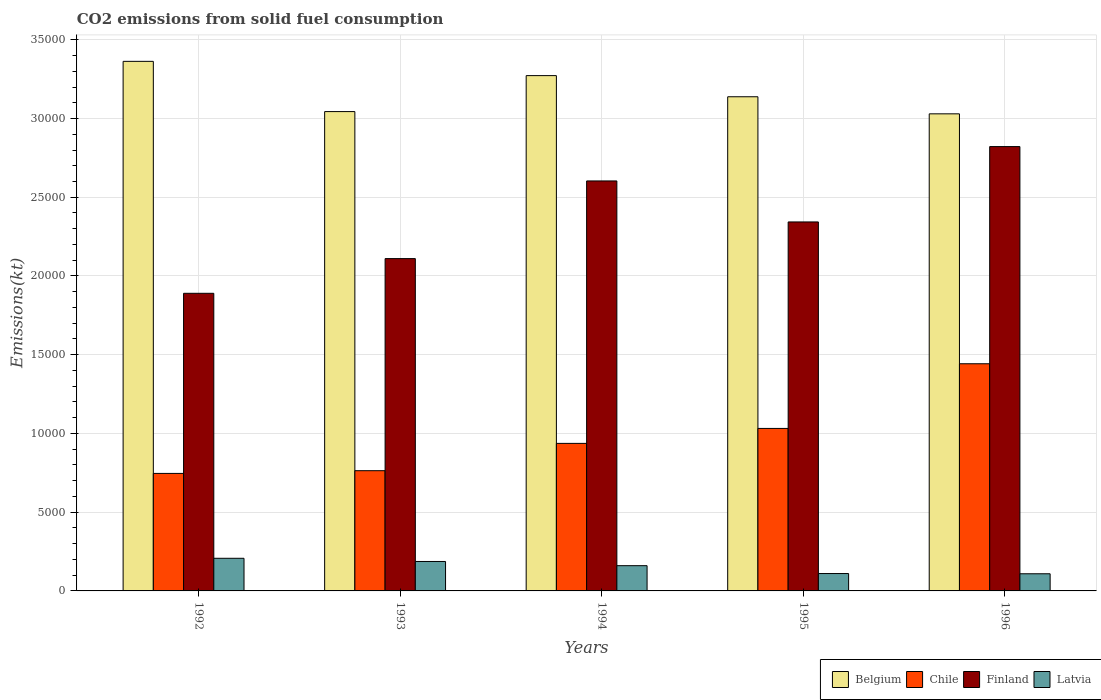How many different coloured bars are there?
Provide a short and direct response. 4. Are the number of bars per tick equal to the number of legend labels?
Your response must be concise. Yes. Are the number of bars on each tick of the X-axis equal?
Offer a terse response. Yes. How many bars are there on the 1st tick from the right?
Offer a very short reply. 4. In how many cases, is the number of bars for a given year not equal to the number of legend labels?
Provide a succinct answer. 0. What is the amount of CO2 emitted in Finland in 1994?
Your answer should be very brief. 2.60e+04. Across all years, what is the maximum amount of CO2 emitted in Finland?
Keep it short and to the point. 2.82e+04. Across all years, what is the minimum amount of CO2 emitted in Latvia?
Make the answer very short. 1089.1. In which year was the amount of CO2 emitted in Latvia maximum?
Offer a terse response. 1992. What is the total amount of CO2 emitted in Chile in the graph?
Provide a succinct answer. 4.92e+04. What is the difference between the amount of CO2 emitted in Chile in 1994 and that in 1996?
Make the answer very short. -5056.79. What is the difference between the amount of CO2 emitted in Belgium in 1992 and the amount of CO2 emitted in Latvia in 1993?
Provide a short and direct response. 3.18e+04. What is the average amount of CO2 emitted in Chile per year?
Your response must be concise. 9842.23. In the year 1992, what is the difference between the amount of CO2 emitted in Chile and amount of CO2 emitted in Latvia?
Keep it short and to the point. 5390.49. What is the ratio of the amount of CO2 emitted in Latvia in 1993 to that in 1996?
Your response must be concise. 1.72. Is the difference between the amount of CO2 emitted in Chile in 1992 and 1994 greater than the difference between the amount of CO2 emitted in Latvia in 1992 and 1994?
Offer a terse response. No. What is the difference between the highest and the second highest amount of CO2 emitted in Latvia?
Your response must be concise. 201.68. What is the difference between the highest and the lowest amount of CO2 emitted in Chile?
Your answer should be compact. 6963.63. Is the sum of the amount of CO2 emitted in Chile in 1995 and 1996 greater than the maximum amount of CO2 emitted in Latvia across all years?
Your answer should be very brief. Yes. What does the 4th bar from the left in 1993 represents?
Offer a terse response. Latvia. What does the 1st bar from the right in 1993 represents?
Ensure brevity in your answer.  Latvia. How many bars are there?
Give a very brief answer. 20. How many legend labels are there?
Ensure brevity in your answer.  4. What is the title of the graph?
Offer a very short reply. CO2 emissions from solid fuel consumption. Does "American Samoa" appear as one of the legend labels in the graph?
Ensure brevity in your answer.  No. What is the label or title of the Y-axis?
Your response must be concise. Emissions(kt). What is the Emissions(kt) of Belgium in 1992?
Provide a succinct answer. 3.36e+04. What is the Emissions(kt) of Chile in 1992?
Make the answer very short. 7462.35. What is the Emissions(kt) of Finland in 1992?
Offer a very short reply. 1.89e+04. What is the Emissions(kt) of Latvia in 1992?
Make the answer very short. 2071.86. What is the Emissions(kt) of Belgium in 1993?
Provide a short and direct response. 3.04e+04. What is the Emissions(kt) of Chile in 1993?
Offer a terse response. 7634.69. What is the Emissions(kt) in Finland in 1993?
Offer a very short reply. 2.11e+04. What is the Emissions(kt) of Latvia in 1993?
Your answer should be compact. 1870.17. What is the Emissions(kt) of Belgium in 1994?
Give a very brief answer. 3.27e+04. What is the Emissions(kt) in Chile in 1994?
Your answer should be very brief. 9369.18. What is the Emissions(kt) in Finland in 1994?
Make the answer very short. 2.60e+04. What is the Emissions(kt) of Latvia in 1994?
Ensure brevity in your answer.  1602.48. What is the Emissions(kt) in Belgium in 1995?
Keep it short and to the point. 3.14e+04. What is the Emissions(kt) of Chile in 1995?
Your answer should be very brief. 1.03e+04. What is the Emissions(kt) in Finland in 1995?
Your answer should be very brief. 2.34e+04. What is the Emissions(kt) of Latvia in 1995?
Offer a terse response. 1103.77. What is the Emissions(kt) of Belgium in 1996?
Make the answer very short. 3.03e+04. What is the Emissions(kt) of Chile in 1996?
Provide a succinct answer. 1.44e+04. What is the Emissions(kt) of Finland in 1996?
Give a very brief answer. 2.82e+04. What is the Emissions(kt) in Latvia in 1996?
Your response must be concise. 1089.1. Across all years, what is the maximum Emissions(kt) in Belgium?
Provide a succinct answer. 3.36e+04. Across all years, what is the maximum Emissions(kt) in Chile?
Your response must be concise. 1.44e+04. Across all years, what is the maximum Emissions(kt) in Finland?
Your answer should be compact. 2.82e+04. Across all years, what is the maximum Emissions(kt) in Latvia?
Your answer should be compact. 2071.86. Across all years, what is the minimum Emissions(kt) of Belgium?
Your answer should be compact. 3.03e+04. Across all years, what is the minimum Emissions(kt) of Chile?
Your answer should be compact. 7462.35. Across all years, what is the minimum Emissions(kt) of Finland?
Offer a terse response. 1.89e+04. Across all years, what is the minimum Emissions(kt) of Latvia?
Your answer should be compact. 1089.1. What is the total Emissions(kt) in Belgium in the graph?
Provide a succinct answer. 1.58e+05. What is the total Emissions(kt) in Chile in the graph?
Keep it short and to the point. 4.92e+04. What is the total Emissions(kt) of Finland in the graph?
Give a very brief answer. 1.18e+05. What is the total Emissions(kt) of Latvia in the graph?
Give a very brief answer. 7737.37. What is the difference between the Emissions(kt) of Belgium in 1992 and that in 1993?
Offer a terse response. 3190.29. What is the difference between the Emissions(kt) in Chile in 1992 and that in 1993?
Offer a very short reply. -172.35. What is the difference between the Emissions(kt) in Finland in 1992 and that in 1993?
Make the answer very short. -2203.87. What is the difference between the Emissions(kt) of Latvia in 1992 and that in 1993?
Offer a terse response. 201.69. What is the difference between the Emissions(kt) in Belgium in 1992 and that in 1994?
Offer a very short reply. 905.75. What is the difference between the Emissions(kt) of Chile in 1992 and that in 1994?
Your answer should be compact. -1906.84. What is the difference between the Emissions(kt) in Finland in 1992 and that in 1994?
Your answer should be very brief. -7135.98. What is the difference between the Emissions(kt) of Latvia in 1992 and that in 1994?
Ensure brevity in your answer.  469.38. What is the difference between the Emissions(kt) of Belgium in 1992 and that in 1995?
Provide a succinct answer. 2247.87. What is the difference between the Emissions(kt) in Chile in 1992 and that in 1995?
Provide a succinct answer. -2856.59. What is the difference between the Emissions(kt) of Finland in 1992 and that in 1995?
Make the answer very short. -4532.41. What is the difference between the Emissions(kt) of Latvia in 1992 and that in 1995?
Your answer should be very brief. 968.09. What is the difference between the Emissions(kt) of Belgium in 1992 and that in 1996?
Ensure brevity in your answer.  3333.3. What is the difference between the Emissions(kt) of Chile in 1992 and that in 1996?
Provide a succinct answer. -6963.63. What is the difference between the Emissions(kt) of Finland in 1992 and that in 1996?
Your answer should be compact. -9317.85. What is the difference between the Emissions(kt) in Latvia in 1992 and that in 1996?
Your answer should be very brief. 982.76. What is the difference between the Emissions(kt) of Belgium in 1993 and that in 1994?
Your answer should be very brief. -2284.54. What is the difference between the Emissions(kt) in Chile in 1993 and that in 1994?
Provide a short and direct response. -1734.49. What is the difference between the Emissions(kt) of Finland in 1993 and that in 1994?
Provide a succinct answer. -4932.11. What is the difference between the Emissions(kt) of Latvia in 1993 and that in 1994?
Your answer should be compact. 267.69. What is the difference between the Emissions(kt) in Belgium in 1993 and that in 1995?
Offer a terse response. -942.42. What is the difference between the Emissions(kt) in Chile in 1993 and that in 1995?
Provide a short and direct response. -2684.24. What is the difference between the Emissions(kt) of Finland in 1993 and that in 1995?
Make the answer very short. -2328.55. What is the difference between the Emissions(kt) of Latvia in 1993 and that in 1995?
Make the answer very short. 766.4. What is the difference between the Emissions(kt) in Belgium in 1993 and that in 1996?
Offer a terse response. 143.01. What is the difference between the Emissions(kt) of Chile in 1993 and that in 1996?
Your response must be concise. -6791.28. What is the difference between the Emissions(kt) of Finland in 1993 and that in 1996?
Your answer should be very brief. -7113.98. What is the difference between the Emissions(kt) of Latvia in 1993 and that in 1996?
Your response must be concise. 781.07. What is the difference between the Emissions(kt) in Belgium in 1994 and that in 1995?
Give a very brief answer. 1342.12. What is the difference between the Emissions(kt) of Chile in 1994 and that in 1995?
Keep it short and to the point. -949.75. What is the difference between the Emissions(kt) in Finland in 1994 and that in 1995?
Provide a short and direct response. 2603.57. What is the difference between the Emissions(kt) in Latvia in 1994 and that in 1995?
Provide a succinct answer. 498.71. What is the difference between the Emissions(kt) in Belgium in 1994 and that in 1996?
Ensure brevity in your answer.  2427.55. What is the difference between the Emissions(kt) of Chile in 1994 and that in 1996?
Give a very brief answer. -5056.79. What is the difference between the Emissions(kt) in Finland in 1994 and that in 1996?
Your response must be concise. -2181.86. What is the difference between the Emissions(kt) in Latvia in 1994 and that in 1996?
Your answer should be compact. 513.38. What is the difference between the Emissions(kt) of Belgium in 1995 and that in 1996?
Your answer should be very brief. 1085.43. What is the difference between the Emissions(kt) in Chile in 1995 and that in 1996?
Offer a terse response. -4107.04. What is the difference between the Emissions(kt) in Finland in 1995 and that in 1996?
Keep it short and to the point. -4785.44. What is the difference between the Emissions(kt) of Latvia in 1995 and that in 1996?
Ensure brevity in your answer.  14.67. What is the difference between the Emissions(kt) in Belgium in 1992 and the Emissions(kt) in Chile in 1993?
Your answer should be compact. 2.60e+04. What is the difference between the Emissions(kt) in Belgium in 1992 and the Emissions(kt) in Finland in 1993?
Keep it short and to the point. 1.25e+04. What is the difference between the Emissions(kt) of Belgium in 1992 and the Emissions(kt) of Latvia in 1993?
Offer a very short reply. 3.18e+04. What is the difference between the Emissions(kt) in Chile in 1992 and the Emissions(kt) in Finland in 1993?
Keep it short and to the point. -1.36e+04. What is the difference between the Emissions(kt) in Chile in 1992 and the Emissions(kt) in Latvia in 1993?
Your answer should be very brief. 5592.18. What is the difference between the Emissions(kt) of Finland in 1992 and the Emissions(kt) of Latvia in 1993?
Give a very brief answer. 1.70e+04. What is the difference between the Emissions(kt) of Belgium in 1992 and the Emissions(kt) of Chile in 1994?
Offer a very short reply. 2.43e+04. What is the difference between the Emissions(kt) of Belgium in 1992 and the Emissions(kt) of Finland in 1994?
Your answer should be compact. 7594.36. What is the difference between the Emissions(kt) of Belgium in 1992 and the Emissions(kt) of Latvia in 1994?
Ensure brevity in your answer.  3.20e+04. What is the difference between the Emissions(kt) of Chile in 1992 and the Emissions(kt) of Finland in 1994?
Offer a very short reply. -1.86e+04. What is the difference between the Emissions(kt) in Chile in 1992 and the Emissions(kt) in Latvia in 1994?
Ensure brevity in your answer.  5859.87. What is the difference between the Emissions(kt) in Finland in 1992 and the Emissions(kt) in Latvia in 1994?
Make the answer very short. 1.73e+04. What is the difference between the Emissions(kt) of Belgium in 1992 and the Emissions(kt) of Chile in 1995?
Offer a very short reply. 2.33e+04. What is the difference between the Emissions(kt) in Belgium in 1992 and the Emissions(kt) in Finland in 1995?
Your response must be concise. 1.02e+04. What is the difference between the Emissions(kt) of Belgium in 1992 and the Emissions(kt) of Latvia in 1995?
Provide a short and direct response. 3.25e+04. What is the difference between the Emissions(kt) in Chile in 1992 and the Emissions(kt) in Finland in 1995?
Your answer should be compact. -1.60e+04. What is the difference between the Emissions(kt) of Chile in 1992 and the Emissions(kt) of Latvia in 1995?
Give a very brief answer. 6358.58. What is the difference between the Emissions(kt) in Finland in 1992 and the Emissions(kt) in Latvia in 1995?
Ensure brevity in your answer.  1.78e+04. What is the difference between the Emissions(kt) in Belgium in 1992 and the Emissions(kt) in Chile in 1996?
Give a very brief answer. 1.92e+04. What is the difference between the Emissions(kt) of Belgium in 1992 and the Emissions(kt) of Finland in 1996?
Keep it short and to the point. 5412.49. What is the difference between the Emissions(kt) of Belgium in 1992 and the Emissions(kt) of Latvia in 1996?
Your response must be concise. 3.25e+04. What is the difference between the Emissions(kt) of Chile in 1992 and the Emissions(kt) of Finland in 1996?
Keep it short and to the point. -2.08e+04. What is the difference between the Emissions(kt) in Chile in 1992 and the Emissions(kt) in Latvia in 1996?
Your response must be concise. 6373.25. What is the difference between the Emissions(kt) in Finland in 1992 and the Emissions(kt) in Latvia in 1996?
Your response must be concise. 1.78e+04. What is the difference between the Emissions(kt) in Belgium in 1993 and the Emissions(kt) in Chile in 1994?
Provide a succinct answer. 2.11e+04. What is the difference between the Emissions(kt) in Belgium in 1993 and the Emissions(kt) in Finland in 1994?
Ensure brevity in your answer.  4404.07. What is the difference between the Emissions(kt) of Belgium in 1993 and the Emissions(kt) of Latvia in 1994?
Offer a very short reply. 2.88e+04. What is the difference between the Emissions(kt) in Chile in 1993 and the Emissions(kt) in Finland in 1994?
Ensure brevity in your answer.  -1.84e+04. What is the difference between the Emissions(kt) of Chile in 1993 and the Emissions(kt) of Latvia in 1994?
Your answer should be compact. 6032.22. What is the difference between the Emissions(kt) of Finland in 1993 and the Emissions(kt) of Latvia in 1994?
Give a very brief answer. 1.95e+04. What is the difference between the Emissions(kt) of Belgium in 1993 and the Emissions(kt) of Chile in 1995?
Offer a very short reply. 2.01e+04. What is the difference between the Emissions(kt) in Belgium in 1993 and the Emissions(kt) in Finland in 1995?
Your answer should be very brief. 7007.64. What is the difference between the Emissions(kt) in Belgium in 1993 and the Emissions(kt) in Latvia in 1995?
Your answer should be very brief. 2.93e+04. What is the difference between the Emissions(kt) in Chile in 1993 and the Emissions(kt) in Finland in 1995?
Your answer should be compact. -1.58e+04. What is the difference between the Emissions(kt) in Chile in 1993 and the Emissions(kt) in Latvia in 1995?
Offer a terse response. 6530.93. What is the difference between the Emissions(kt) in Finland in 1993 and the Emissions(kt) in Latvia in 1995?
Provide a succinct answer. 2.00e+04. What is the difference between the Emissions(kt) in Belgium in 1993 and the Emissions(kt) in Chile in 1996?
Provide a succinct answer. 1.60e+04. What is the difference between the Emissions(kt) of Belgium in 1993 and the Emissions(kt) of Finland in 1996?
Offer a very short reply. 2222.2. What is the difference between the Emissions(kt) in Belgium in 1993 and the Emissions(kt) in Latvia in 1996?
Offer a very short reply. 2.94e+04. What is the difference between the Emissions(kt) in Chile in 1993 and the Emissions(kt) in Finland in 1996?
Provide a succinct answer. -2.06e+04. What is the difference between the Emissions(kt) of Chile in 1993 and the Emissions(kt) of Latvia in 1996?
Your response must be concise. 6545.6. What is the difference between the Emissions(kt) in Finland in 1993 and the Emissions(kt) in Latvia in 1996?
Offer a very short reply. 2.00e+04. What is the difference between the Emissions(kt) in Belgium in 1994 and the Emissions(kt) in Chile in 1995?
Provide a succinct answer. 2.24e+04. What is the difference between the Emissions(kt) in Belgium in 1994 and the Emissions(kt) in Finland in 1995?
Offer a very short reply. 9292.18. What is the difference between the Emissions(kt) of Belgium in 1994 and the Emissions(kt) of Latvia in 1995?
Your response must be concise. 3.16e+04. What is the difference between the Emissions(kt) in Chile in 1994 and the Emissions(kt) in Finland in 1995?
Offer a terse response. -1.41e+04. What is the difference between the Emissions(kt) in Chile in 1994 and the Emissions(kt) in Latvia in 1995?
Ensure brevity in your answer.  8265.42. What is the difference between the Emissions(kt) in Finland in 1994 and the Emissions(kt) in Latvia in 1995?
Your answer should be compact. 2.49e+04. What is the difference between the Emissions(kt) in Belgium in 1994 and the Emissions(kt) in Chile in 1996?
Your answer should be compact. 1.83e+04. What is the difference between the Emissions(kt) in Belgium in 1994 and the Emissions(kt) in Finland in 1996?
Your answer should be compact. 4506.74. What is the difference between the Emissions(kt) of Belgium in 1994 and the Emissions(kt) of Latvia in 1996?
Offer a very short reply. 3.16e+04. What is the difference between the Emissions(kt) of Chile in 1994 and the Emissions(kt) of Finland in 1996?
Give a very brief answer. -1.88e+04. What is the difference between the Emissions(kt) in Chile in 1994 and the Emissions(kt) in Latvia in 1996?
Your answer should be compact. 8280.09. What is the difference between the Emissions(kt) of Finland in 1994 and the Emissions(kt) of Latvia in 1996?
Provide a short and direct response. 2.49e+04. What is the difference between the Emissions(kt) of Belgium in 1995 and the Emissions(kt) of Chile in 1996?
Ensure brevity in your answer.  1.70e+04. What is the difference between the Emissions(kt) of Belgium in 1995 and the Emissions(kt) of Finland in 1996?
Give a very brief answer. 3164.62. What is the difference between the Emissions(kt) of Belgium in 1995 and the Emissions(kt) of Latvia in 1996?
Give a very brief answer. 3.03e+04. What is the difference between the Emissions(kt) in Chile in 1995 and the Emissions(kt) in Finland in 1996?
Your response must be concise. -1.79e+04. What is the difference between the Emissions(kt) in Chile in 1995 and the Emissions(kt) in Latvia in 1996?
Your answer should be compact. 9229.84. What is the difference between the Emissions(kt) of Finland in 1995 and the Emissions(kt) of Latvia in 1996?
Your answer should be very brief. 2.23e+04. What is the average Emissions(kt) of Belgium per year?
Ensure brevity in your answer.  3.17e+04. What is the average Emissions(kt) in Chile per year?
Offer a very short reply. 9842.23. What is the average Emissions(kt) of Finland per year?
Your answer should be very brief. 2.35e+04. What is the average Emissions(kt) of Latvia per year?
Ensure brevity in your answer.  1547.47. In the year 1992, what is the difference between the Emissions(kt) in Belgium and Emissions(kt) in Chile?
Your answer should be compact. 2.62e+04. In the year 1992, what is the difference between the Emissions(kt) in Belgium and Emissions(kt) in Finland?
Make the answer very short. 1.47e+04. In the year 1992, what is the difference between the Emissions(kt) in Belgium and Emissions(kt) in Latvia?
Keep it short and to the point. 3.16e+04. In the year 1992, what is the difference between the Emissions(kt) in Chile and Emissions(kt) in Finland?
Your response must be concise. -1.14e+04. In the year 1992, what is the difference between the Emissions(kt) of Chile and Emissions(kt) of Latvia?
Make the answer very short. 5390.49. In the year 1992, what is the difference between the Emissions(kt) in Finland and Emissions(kt) in Latvia?
Make the answer very short. 1.68e+04. In the year 1993, what is the difference between the Emissions(kt) in Belgium and Emissions(kt) in Chile?
Keep it short and to the point. 2.28e+04. In the year 1993, what is the difference between the Emissions(kt) of Belgium and Emissions(kt) of Finland?
Offer a terse response. 9336.18. In the year 1993, what is the difference between the Emissions(kt) of Belgium and Emissions(kt) of Latvia?
Ensure brevity in your answer.  2.86e+04. In the year 1993, what is the difference between the Emissions(kt) in Chile and Emissions(kt) in Finland?
Give a very brief answer. -1.35e+04. In the year 1993, what is the difference between the Emissions(kt) in Chile and Emissions(kt) in Latvia?
Your answer should be compact. 5764.52. In the year 1993, what is the difference between the Emissions(kt) of Finland and Emissions(kt) of Latvia?
Give a very brief answer. 1.92e+04. In the year 1994, what is the difference between the Emissions(kt) of Belgium and Emissions(kt) of Chile?
Provide a succinct answer. 2.34e+04. In the year 1994, what is the difference between the Emissions(kt) in Belgium and Emissions(kt) in Finland?
Keep it short and to the point. 6688.61. In the year 1994, what is the difference between the Emissions(kt) in Belgium and Emissions(kt) in Latvia?
Keep it short and to the point. 3.11e+04. In the year 1994, what is the difference between the Emissions(kt) in Chile and Emissions(kt) in Finland?
Give a very brief answer. -1.67e+04. In the year 1994, what is the difference between the Emissions(kt) of Chile and Emissions(kt) of Latvia?
Offer a very short reply. 7766.71. In the year 1994, what is the difference between the Emissions(kt) of Finland and Emissions(kt) of Latvia?
Offer a very short reply. 2.44e+04. In the year 1995, what is the difference between the Emissions(kt) of Belgium and Emissions(kt) of Chile?
Make the answer very short. 2.11e+04. In the year 1995, what is the difference between the Emissions(kt) of Belgium and Emissions(kt) of Finland?
Your response must be concise. 7950.06. In the year 1995, what is the difference between the Emissions(kt) of Belgium and Emissions(kt) of Latvia?
Ensure brevity in your answer.  3.03e+04. In the year 1995, what is the difference between the Emissions(kt) of Chile and Emissions(kt) of Finland?
Provide a succinct answer. -1.31e+04. In the year 1995, what is the difference between the Emissions(kt) in Chile and Emissions(kt) in Latvia?
Ensure brevity in your answer.  9215.17. In the year 1995, what is the difference between the Emissions(kt) of Finland and Emissions(kt) of Latvia?
Provide a short and direct response. 2.23e+04. In the year 1996, what is the difference between the Emissions(kt) in Belgium and Emissions(kt) in Chile?
Offer a terse response. 1.59e+04. In the year 1996, what is the difference between the Emissions(kt) in Belgium and Emissions(kt) in Finland?
Ensure brevity in your answer.  2079.19. In the year 1996, what is the difference between the Emissions(kt) in Belgium and Emissions(kt) in Latvia?
Your response must be concise. 2.92e+04. In the year 1996, what is the difference between the Emissions(kt) of Chile and Emissions(kt) of Finland?
Your answer should be compact. -1.38e+04. In the year 1996, what is the difference between the Emissions(kt) in Chile and Emissions(kt) in Latvia?
Your response must be concise. 1.33e+04. In the year 1996, what is the difference between the Emissions(kt) of Finland and Emissions(kt) of Latvia?
Make the answer very short. 2.71e+04. What is the ratio of the Emissions(kt) in Belgium in 1992 to that in 1993?
Provide a short and direct response. 1.1. What is the ratio of the Emissions(kt) of Chile in 1992 to that in 1993?
Keep it short and to the point. 0.98. What is the ratio of the Emissions(kt) in Finland in 1992 to that in 1993?
Give a very brief answer. 0.9. What is the ratio of the Emissions(kt) in Latvia in 1992 to that in 1993?
Your response must be concise. 1.11. What is the ratio of the Emissions(kt) of Belgium in 1992 to that in 1994?
Ensure brevity in your answer.  1.03. What is the ratio of the Emissions(kt) in Chile in 1992 to that in 1994?
Your response must be concise. 0.8. What is the ratio of the Emissions(kt) in Finland in 1992 to that in 1994?
Your answer should be very brief. 0.73. What is the ratio of the Emissions(kt) of Latvia in 1992 to that in 1994?
Offer a terse response. 1.29. What is the ratio of the Emissions(kt) of Belgium in 1992 to that in 1995?
Keep it short and to the point. 1.07. What is the ratio of the Emissions(kt) of Chile in 1992 to that in 1995?
Keep it short and to the point. 0.72. What is the ratio of the Emissions(kt) in Finland in 1992 to that in 1995?
Your answer should be compact. 0.81. What is the ratio of the Emissions(kt) of Latvia in 1992 to that in 1995?
Your answer should be compact. 1.88. What is the ratio of the Emissions(kt) in Belgium in 1992 to that in 1996?
Offer a very short reply. 1.11. What is the ratio of the Emissions(kt) in Chile in 1992 to that in 1996?
Offer a terse response. 0.52. What is the ratio of the Emissions(kt) in Finland in 1992 to that in 1996?
Give a very brief answer. 0.67. What is the ratio of the Emissions(kt) of Latvia in 1992 to that in 1996?
Offer a very short reply. 1.9. What is the ratio of the Emissions(kt) of Belgium in 1993 to that in 1994?
Your answer should be very brief. 0.93. What is the ratio of the Emissions(kt) of Chile in 1993 to that in 1994?
Your response must be concise. 0.81. What is the ratio of the Emissions(kt) in Finland in 1993 to that in 1994?
Your response must be concise. 0.81. What is the ratio of the Emissions(kt) in Latvia in 1993 to that in 1994?
Make the answer very short. 1.17. What is the ratio of the Emissions(kt) of Chile in 1993 to that in 1995?
Your answer should be compact. 0.74. What is the ratio of the Emissions(kt) of Finland in 1993 to that in 1995?
Keep it short and to the point. 0.9. What is the ratio of the Emissions(kt) of Latvia in 1993 to that in 1995?
Your response must be concise. 1.69. What is the ratio of the Emissions(kt) of Chile in 1993 to that in 1996?
Provide a short and direct response. 0.53. What is the ratio of the Emissions(kt) in Finland in 1993 to that in 1996?
Offer a terse response. 0.75. What is the ratio of the Emissions(kt) of Latvia in 1993 to that in 1996?
Make the answer very short. 1.72. What is the ratio of the Emissions(kt) in Belgium in 1994 to that in 1995?
Provide a short and direct response. 1.04. What is the ratio of the Emissions(kt) in Chile in 1994 to that in 1995?
Ensure brevity in your answer.  0.91. What is the ratio of the Emissions(kt) of Finland in 1994 to that in 1995?
Make the answer very short. 1.11. What is the ratio of the Emissions(kt) in Latvia in 1994 to that in 1995?
Offer a terse response. 1.45. What is the ratio of the Emissions(kt) of Belgium in 1994 to that in 1996?
Your response must be concise. 1.08. What is the ratio of the Emissions(kt) in Chile in 1994 to that in 1996?
Ensure brevity in your answer.  0.65. What is the ratio of the Emissions(kt) in Finland in 1994 to that in 1996?
Offer a terse response. 0.92. What is the ratio of the Emissions(kt) of Latvia in 1994 to that in 1996?
Offer a terse response. 1.47. What is the ratio of the Emissions(kt) in Belgium in 1995 to that in 1996?
Provide a short and direct response. 1.04. What is the ratio of the Emissions(kt) of Chile in 1995 to that in 1996?
Give a very brief answer. 0.72. What is the ratio of the Emissions(kt) in Finland in 1995 to that in 1996?
Provide a short and direct response. 0.83. What is the ratio of the Emissions(kt) in Latvia in 1995 to that in 1996?
Provide a short and direct response. 1.01. What is the difference between the highest and the second highest Emissions(kt) of Belgium?
Your answer should be compact. 905.75. What is the difference between the highest and the second highest Emissions(kt) in Chile?
Offer a very short reply. 4107.04. What is the difference between the highest and the second highest Emissions(kt) in Finland?
Your answer should be very brief. 2181.86. What is the difference between the highest and the second highest Emissions(kt) of Latvia?
Make the answer very short. 201.69. What is the difference between the highest and the lowest Emissions(kt) of Belgium?
Offer a terse response. 3333.3. What is the difference between the highest and the lowest Emissions(kt) in Chile?
Ensure brevity in your answer.  6963.63. What is the difference between the highest and the lowest Emissions(kt) of Finland?
Make the answer very short. 9317.85. What is the difference between the highest and the lowest Emissions(kt) of Latvia?
Make the answer very short. 982.76. 